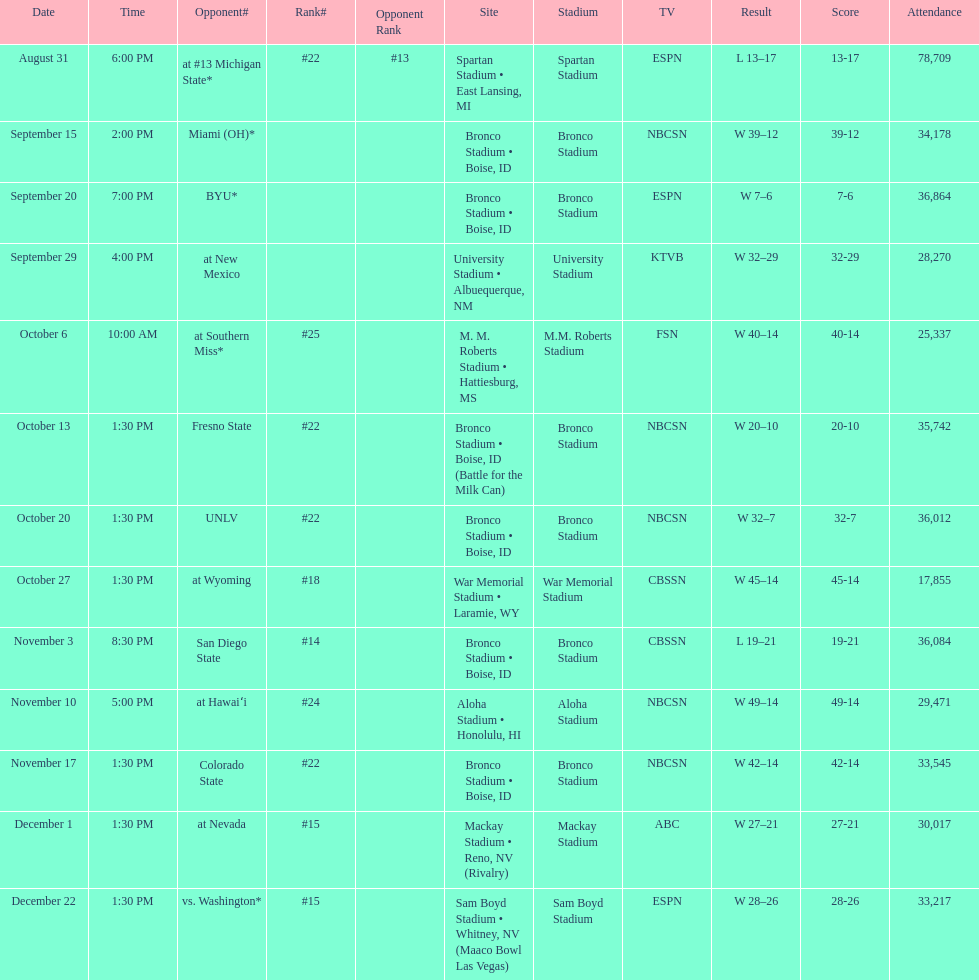What was the most consecutive wins for the team shown in the season? 7. 